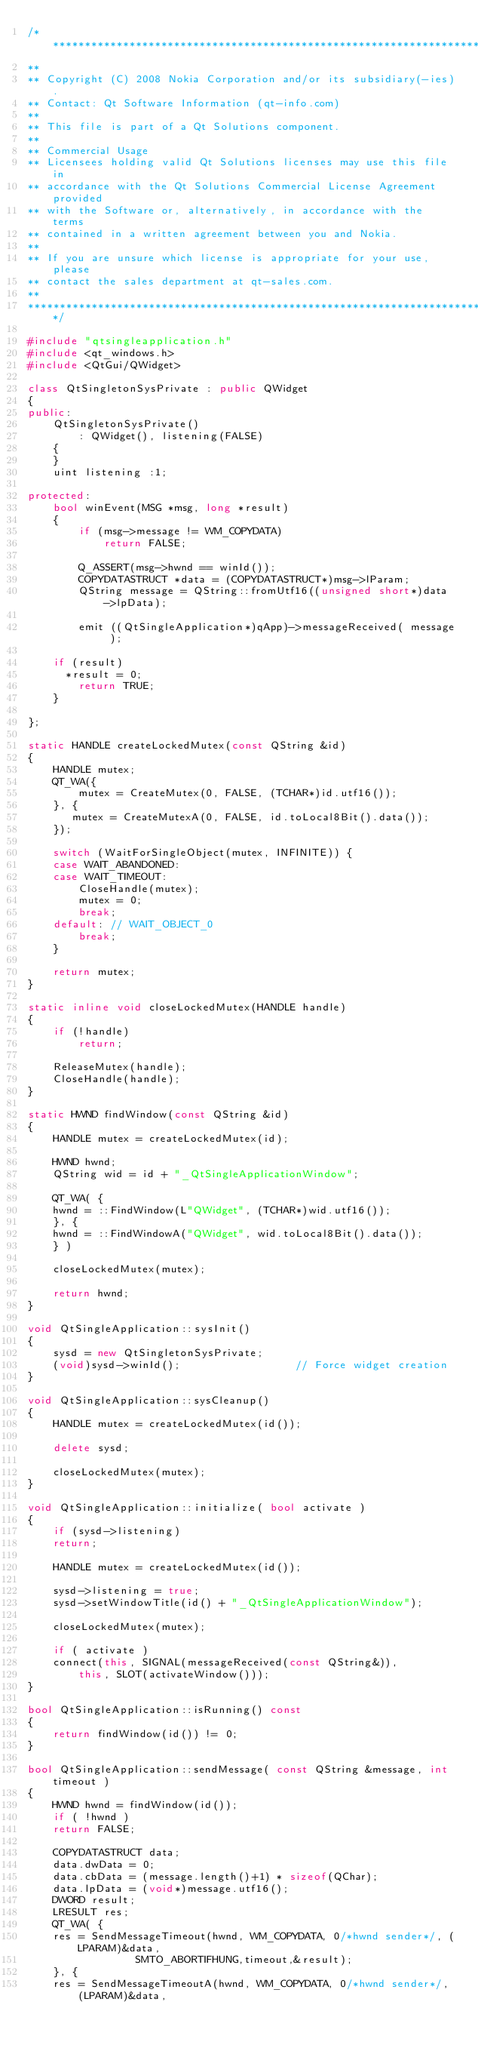<code> <loc_0><loc_0><loc_500><loc_500><_C++_>/****************************************************************************
**
** Copyright (C) 2008 Nokia Corporation and/or its subsidiary(-ies).
** Contact: Qt Software Information (qt-info.com)
**
** This file is part of a Qt Solutions component.
**
** Commercial Usage
** Licensees holding valid Qt Solutions licenses may use this file in
** accordance with the Qt Solutions Commercial License Agreement provided
** with the Software or, alternatively, in accordance with the terms
** contained in a written agreement between you and Nokia.
**
** If you are unsure which license is appropriate for your use, please
** contact the sales department at qt-sales.com.
**
****************************************************************************/

#include "qtsingleapplication.h"
#include <qt_windows.h>
#include <QtGui/QWidget>

class QtSingletonSysPrivate : public QWidget
{
public:
    QtSingletonSysPrivate()
        : QWidget(), listening(FALSE)
    {
    }
    uint listening :1;

protected:
    bool winEvent(MSG *msg, long *result)
    {
        if (msg->message != WM_COPYDATA)
            return FALSE;

        Q_ASSERT(msg->hwnd == winId());
        COPYDATASTRUCT *data = (COPYDATASTRUCT*)msg->lParam;
        QString message = QString::fromUtf16((unsigned short*)data->lpData);

        emit ((QtSingleApplication*)qApp)->messageReceived( message );

	if (result)
	  *result = 0;
        return TRUE;
    }

};

static HANDLE createLockedMutex(const QString &id)
{
    HANDLE mutex;
    QT_WA({
        mutex = CreateMutex(0, FALSE, (TCHAR*)id.utf16());
    }, {
       mutex = CreateMutexA(0, FALSE, id.toLocal8Bit().data());
    });

    switch (WaitForSingleObject(mutex, INFINITE)) {
    case WAIT_ABANDONED:
    case WAIT_TIMEOUT:
        CloseHandle(mutex);
        mutex = 0;
        break;
    default: // WAIT_OBJECT_0
        break;
    }

    return mutex;
}

static inline void closeLockedMutex(HANDLE handle)
{
    if (!handle)
        return;

    ReleaseMutex(handle);
    CloseHandle(handle);
}

static HWND findWindow(const QString &id)
{
    HANDLE mutex = createLockedMutex(id);

    HWND hwnd;
    QString wid = id + "_QtSingleApplicationWindow";

    QT_WA( {
	hwnd = ::FindWindow(L"QWidget", (TCHAR*)wid.utf16());
    }, {
	hwnd = ::FindWindowA("QWidget", wid.toLocal8Bit().data());
    } )

    closeLockedMutex(mutex);

    return hwnd;
}

void QtSingleApplication::sysInit()
{
    sysd = new QtSingletonSysPrivate;
    (void)sysd->winId();                  // Force widget creation
}

void QtSingleApplication::sysCleanup()
{
    HANDLE mutex = createLockedMutex(id());

    delete sysd;

    closeLockedMutex(mutex);
}

void QtSingleApplication::initialize( bool activate )
{
    if (sysd->listening)
	return;

    HANDLE mutex = createLockedMutex(id());

    sysd->listening = true;
    sysd->setWindowTitle(id() + "_QtSingleApplicationWindow");

    closeLockedMutex(mutex);

    if ( activate )
	connect(this, SIGNAL(messageReceived(const QString&)),
		this, SLOT(activateWindow()));
}

bool QtSingleApplication::isRunning() const
{
    return findWindow(id()) != 0;
}

bool QtSingleApplication::sendMessage( const QString &message, int timeout )
{
    HWND hwnd = findWindow(id());
    if ( !hwnd )
	return FALSE;

    COPYDATASTRUCT data;
    data.dwData = 0;
    data.cbData = (message.length()+1) * sizeof(QChar);
    data.lpData = (void*)message.utf16();
    DWORD result;
    LRESULT res;
    QT_WA( {
	res = SendMessageTimeout(hwnd, WM_COPYDATA, 0/*hwnd sender*/, (LPARAM)&data,
				 SMTO_ABORTIFHUNG,timeout,&result);
    }, {
	res = SendMessageTimeoutA(hwnd, WM_COPYDATA, 0/*hwnd sender*/, (LPARAM)&data,</code> 